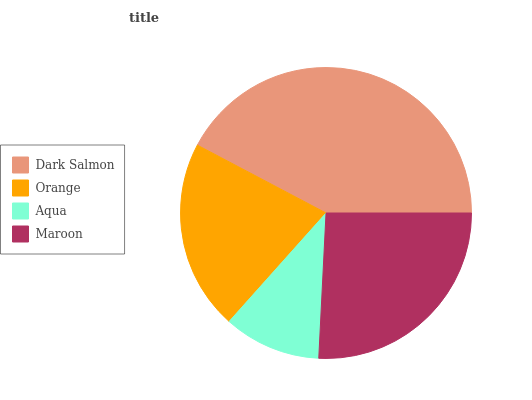Is Aqua the minimum?
Answer yes or no. Yes. Is Dark Salmon the maximum?
Answer yes or no. Yes. Is Orange the minimum?
Answer yes or no. No. Is Orange the maximum?
Answer yes or no. No. Is Dark Salmon greater than Orange?
Answer yes or no. Yes. Is Orange less than Dark Salmon?
Answer yes or no. Yes. Is Orange greater than Dark Salmon?
Answer yes or no. No. Is Dark Salmon less than Orange?
Answer yes or no. No. Is Maroon the high median?
Answer yes or no. Yes. Is Orange the low median?
Answer yes or no. Yes. Is Dark Salmon the high median?
Answer yes or no. No. Is Maroon the low median?
Answer yes or no. No. 